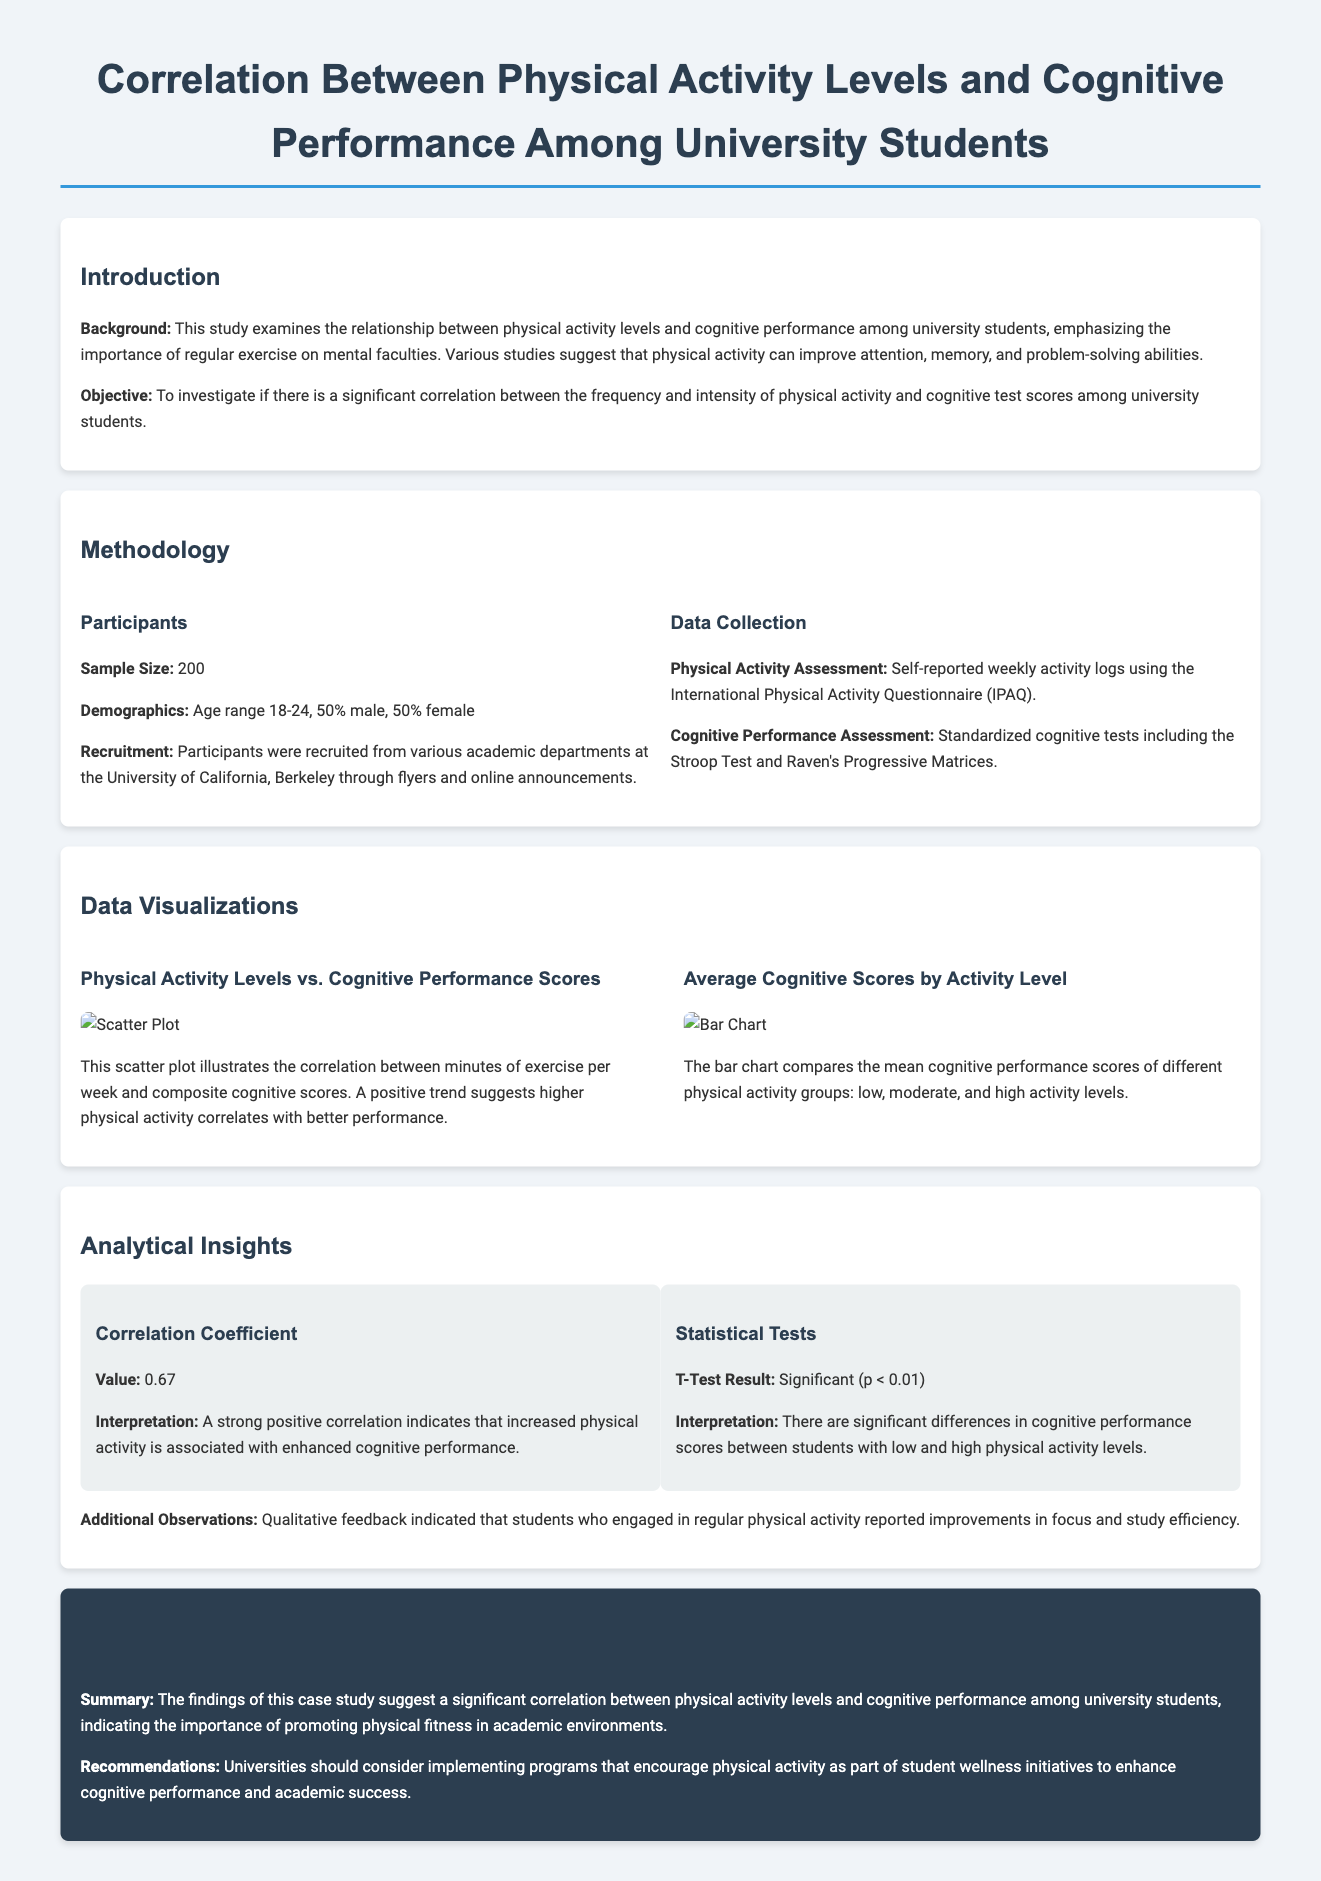What is the sample size of the study? The sample size is a specific detail mentioned under participants, which is 200.
Answer: 200 What are the demographics of the participants? The demographics detail is provided under participants, stating age range and gender distribution.
Answer: Age range 18-24, 50% male, 50% female What is the correlation coefficient found in the study? The correlation coefficient is a critical quantitative finding regarding physical activity and cognitive performance mentioned in analytical insights.
Answer: 0.67 What statistical test result is reported in the study? The statistical test result is mentioned in the document, indicating significance level of the test.
Answer: Significant (p < 0.01) What activities were used for cognitive performance assessment? The activities for assessing cognitive performance include standardized tests, which are explicitly mentioned.
Answer: Stroop Test and Raven's Progressive Matrices What does the bar chart compare? The bar chart specifically illustrates the mean scores of cognitive performance based on different activity groups.
Answer: Mean cognitive performance scores by activity level What do students engaging in regular physical activity report? This detail is found in the observations section, providing insight from qualitative feedback.
Answer: Improvements in focus and study efficiency What is the conclusion of the study regarding physical activity and cognitive performance? The conclusion summarizes the findings of the study as stated in the conclusion section.
Answer: Significant correlation between physical activity levels and cognitive performance 